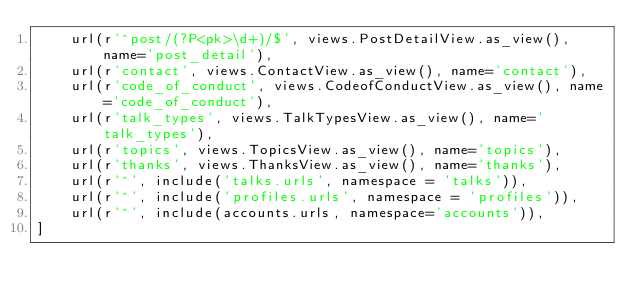Convert code to text. <code><loc_0><loc_0><loc_500><loc_500><_Python_>    url(r'^post/(?P<pk>\d+)/$', views.PostDetailView.as_view(), name='post_detail'),
    url(r'contact', views.ContactView.as_view(), name='contact'),
    url(r'code_of_conduct', views.CodeofConductView.as_view(), name='code_of_conduct'),
    url(r'talk_types', views.TalkTypesView.as_view(), name='talk_types'),
    url(r'topics', views.TopicsView.as_view(), name='topics'),
    url(r'thanks', views.ThanksView.as_view(), name='thanks'),
    url(r'^', include('talks.urls', namespace = 'talks')),
    url(r'^', include('profiles.urls', namespace = 'profiles')),
    url(r'^', include(accounts.urls, namespace='accounts')),
]
</code> 